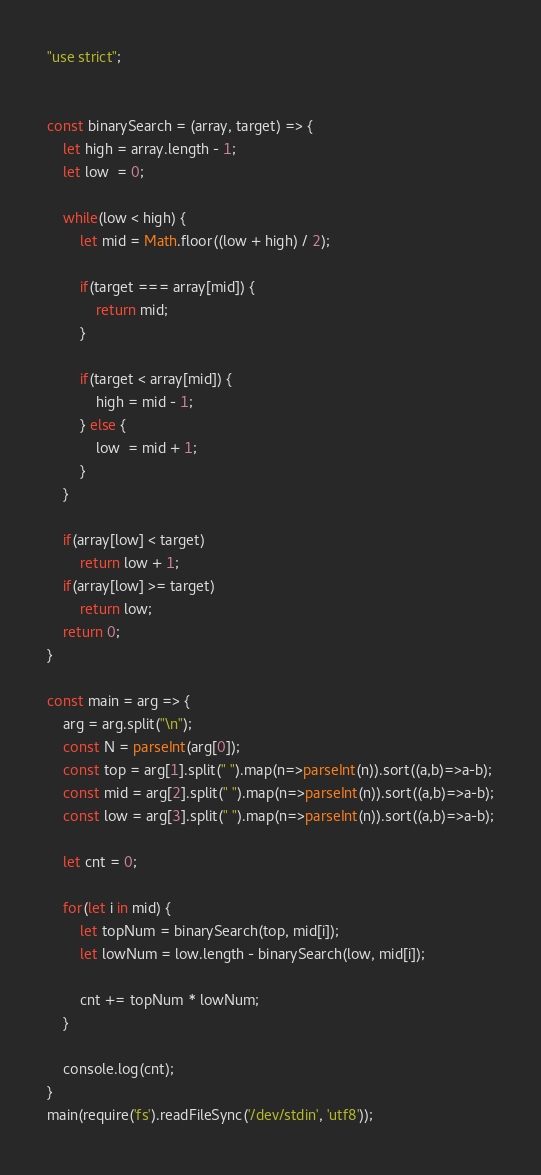Convert code to text. <code><loc_0><loc_0><loc_500><loc_500><_JavaScript_>"use strict";
    

const binarySearch = (array, target) => {
    let high = array.length - 1;
    let low  = 0;
    
    while(low < high) {
        let mid = Math.floor((low + high) / 2); 
        
        if(target === array[mid]) {
            return mid;
        }
        
        if(target < array[mid]) {
            high = mid - 1;
        } else {
            low  = mid + 1;
        }
    }
    
    if(array[low] < target)
        return low + 1;
    if(array[low] >= target)
        return low;
    return 0;
}

const main = arg => {
    arg = arg.split("\n");
    const N = parseInt(arg[0]);
    const top = arg[1].split(" ").map(n=>parseInt(n)).sort((a,b)=>a-b);
    const mid = arg[2].split(" ").map(n=>parseInt(n)).sort((a,b)=>a-b);
    const low = arg[3].split(" ").map(n=>parseInt(n)).sort((a,b)=>a-b);
    
    let cnt = 0;
    
    for(let i in mid) {
        let topNum = binarySearch(top, mid[i]);
        let lowNum = low.length - binarySearch(low, mid[i]);
        
        cnt += topNum * lowNum;
    }
    
    console.log(cnt);
}
main(require('fs').readFileSync('/dev/stdin', 'utf8'));</code> 